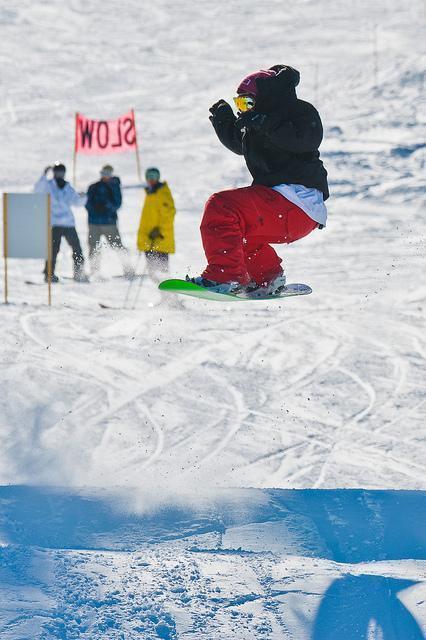How many people are in the picture?
Give a very brief answer. 4. 